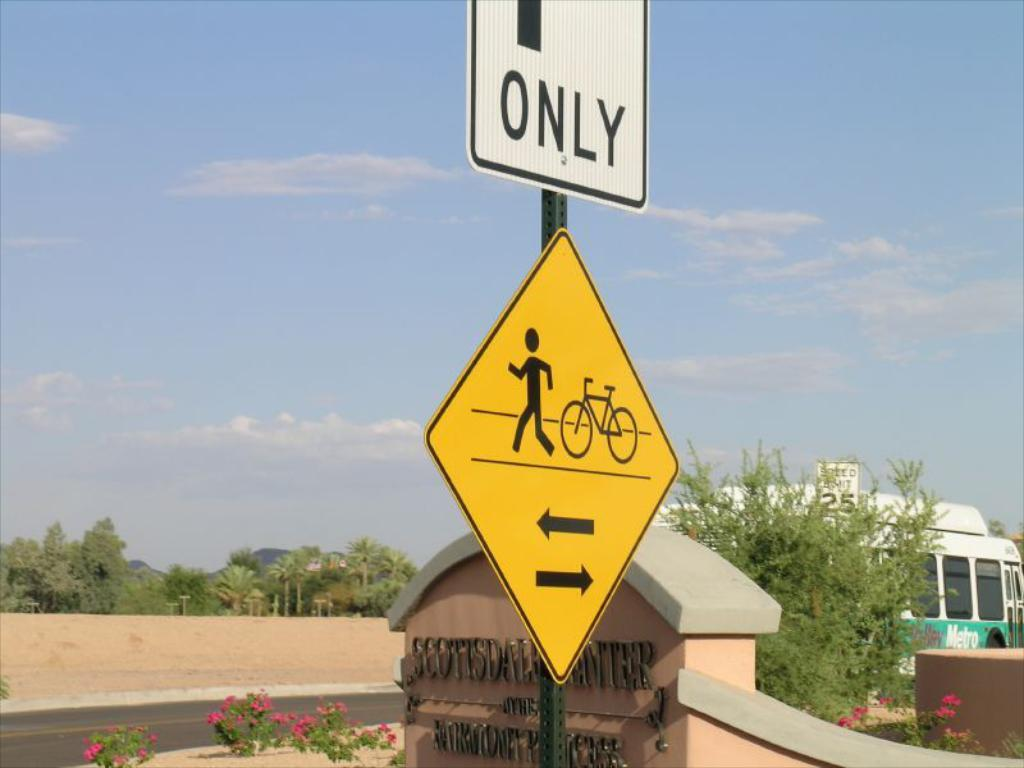<image>
Provide a brief description of the given image. A yellow sign showing a pedestrian and bicycle has a white sign above it that says Only. 